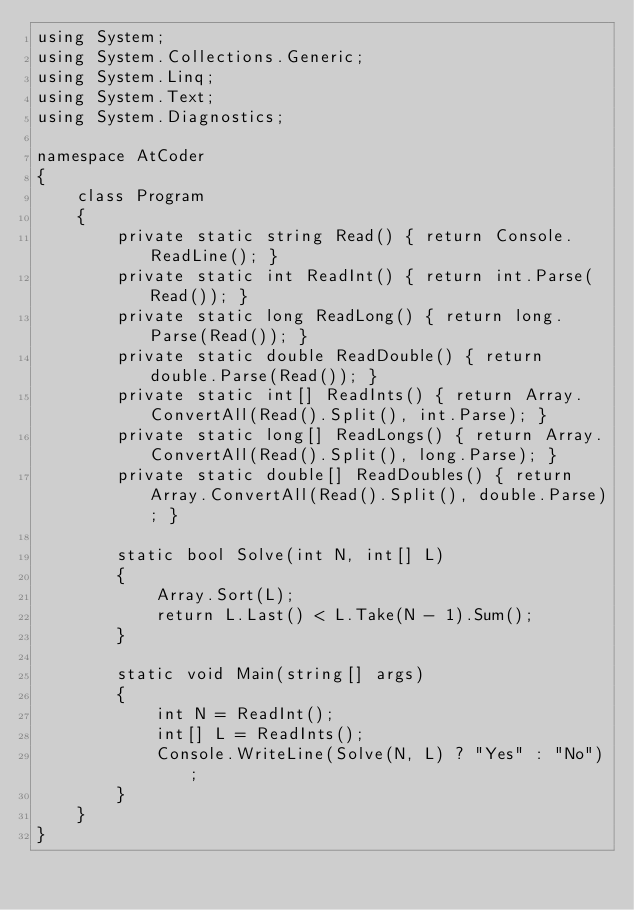<code> <loc_0><loc_0><loc_500><loc_500><_C#_>using System;
using System.Collections.Generic;
using System.Linq;
using System.Text;
using System.Diagnostics;

namespace AtCoder
{
    class Program
    {
        private static string Read() { return Console.ReadLine(); }
        private static int ReadInt() { return int.Parse(Read()); }
        private static long ReadLong() { return long.Parse(Read()); }
        private static double ReadDouble() { return double.Parse(Read()); }
        private static int[] ReadInts() { return Array.ConvertAll(Read().Split(), int.Parse); }
        private static long[] ReadLongs() { return Array.ConvertAll(Read().Split(), long.Parse); }
        private static double[] ReadDoubles() { return Array.ConvertAll(Read().Split(), double.Parse); }

        static bool Solve(int N, int[] L)
        {
            Array.Sort(L);
            return L.Last() < L.Take(N - 1).Sum();
        }

        static void Main(string[] args)
        {
            int N = ReadInt();
            int[] L = ReadInts();
            Console.WriteLine(Solve(N, L) ? "Yes" : "No");
        }
    }
}
</code> 